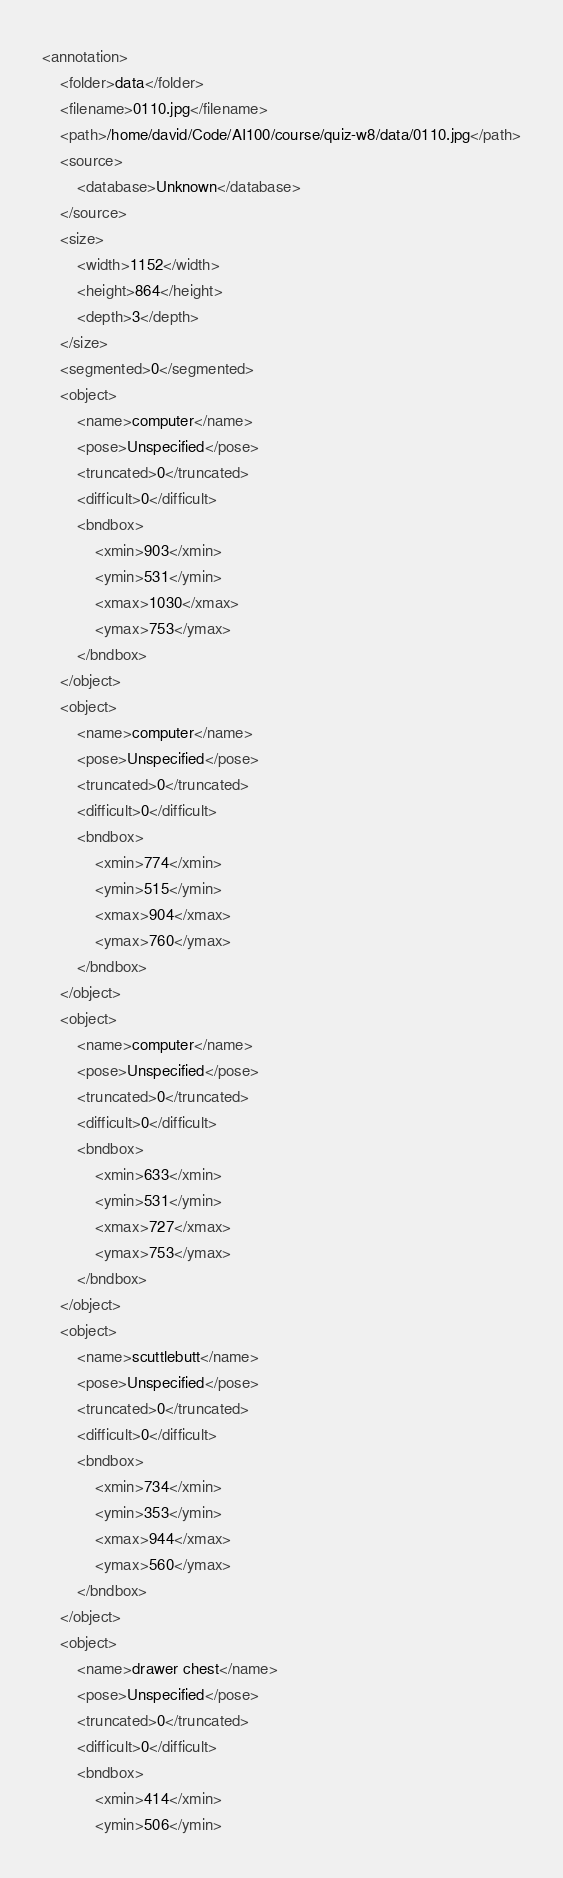<code> <loc_0><loc_0><loc_500><loc_500><_XML_><annotation>
	<folder>data</folder>
	<filename>0110.jpg</filename>
	<path>/home/david/Code/AI100/course/quiz-w8/data/0110.jpg</path>
	<source>
		<database>Unknown</database>
	</source>
	<size>
		<width>1152</width>
		<height>864</height>
		<depth>3</depth>
	</size>
	<segmented>0</segmented>
	<object>
		<name>computer</name>
		<pose>Unspecified</pose>
		<truncated>0</truncated>
		<difficult>0</difficult>
		<bndbox>
			<xmin>903</xmin>
			<ymin>531</ymin>
			<xmax>1030</xmax>
			<ymax>753</ymax>
		</bndbox>
	</object>
	<object>
		<name>computer</name>
		<pose>Unspecified</pose>
		<truncated>0</truncated>
		<difficult>0</difficult>
		<bndbox>
			<xmin>774</xmin>
			<ymin>515</ymin>
			<xmax>904</xmax>
			<ymax>760</ymax>
		</bndbox>
	</object>
	<object>
		<name>computer</name>
		<pose>Unspecified</pose>
		<truncated>0</truncated>
		<difficult>0</difficult>
		<bndbox>
			<xmin>633</xmin>
			<ymin>531</ymin>
			<xmax>727</xmax>
			<ymax>753</ymax>
		</bndbox>
	</object>
	<object>
		<name>scuttlebutt</name>
		<pose>Unspecified</pose>
		<truncated>0</truncated>
		<difficult>0</difficult>
		<bndbox>
			<xmin>734</xmin>
			<ymin>353</ymin>
			<xmax>944</xmax>
			<ymax>560</ymax>
		</bndbox>
	</object>
	<object>
		<name>drawer chest</name>
		<pose>Unspecified</pose>
		<truncated>0</truncated>
		<difficult>0</difficult>
		<bndbox>
			<xmin>414</xmin>
			<ymin>506</ymin></code> 